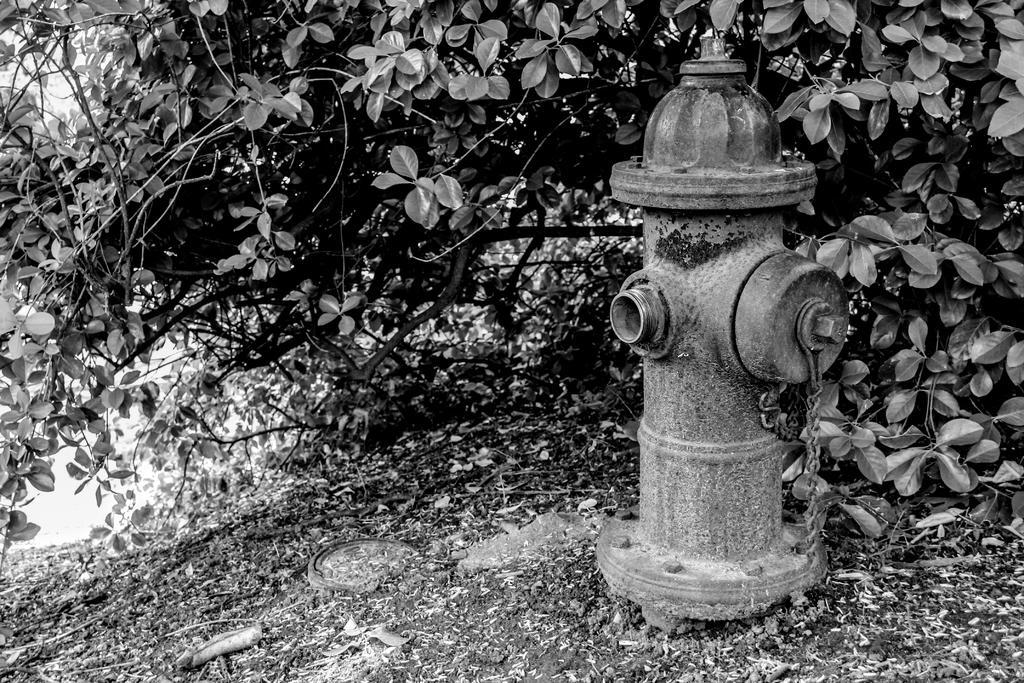Please provide a concise description of this image. In this image there is a fire hydrant on the land. Background there are few plants having leaves. 